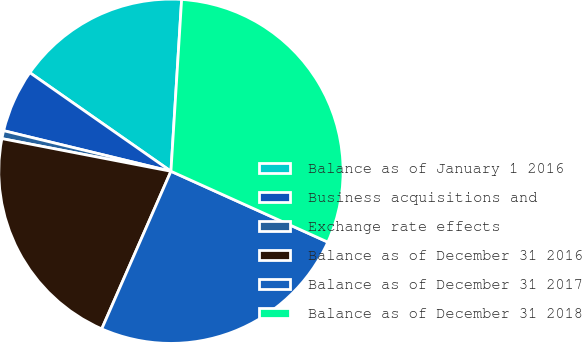Convert chart to OTSL. <chart><loc_0><loc_0><loc_500><loc_500><pie_chart><fcel>Balance as of January 1 2016<fcel>Business acquisitions and<fcel>Exchange rate effects<fcel>Balance as of December 31 2016<fcel>Balance as of December 31 2017<fcel>Balance as of December 31 2018<nl><fcel>16.28%<fcel>5.92%<fcel>0.75%<fcel>21.45%<fcel>24.83%<fcel>30.76%<nl></chart> 